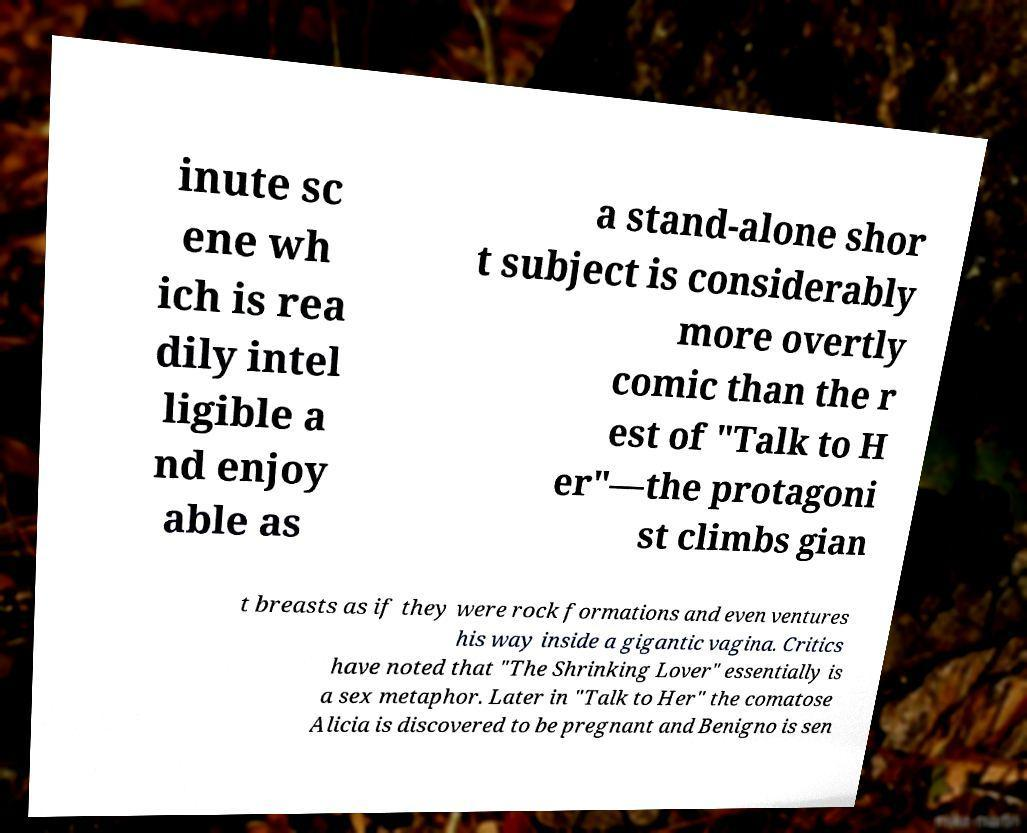Can you accurately transcribe the text from the provided image for me? inute sc ene wh ich is rea dily intel ligible a nd enjoy able as a stand-alone shor t subject is considerably more overtly comic than the r est of "Talk to H er"—the protagoni st climbs gian t breasts as if they were rock formations and even ventures his way inside a gigantic vagina. Critics have noted that "The Shrinking Lover" essentially is a sex metaphor. Later in "Talk to Her" the comatose Alicia is discovered to be pregnant and Benigno is sen 